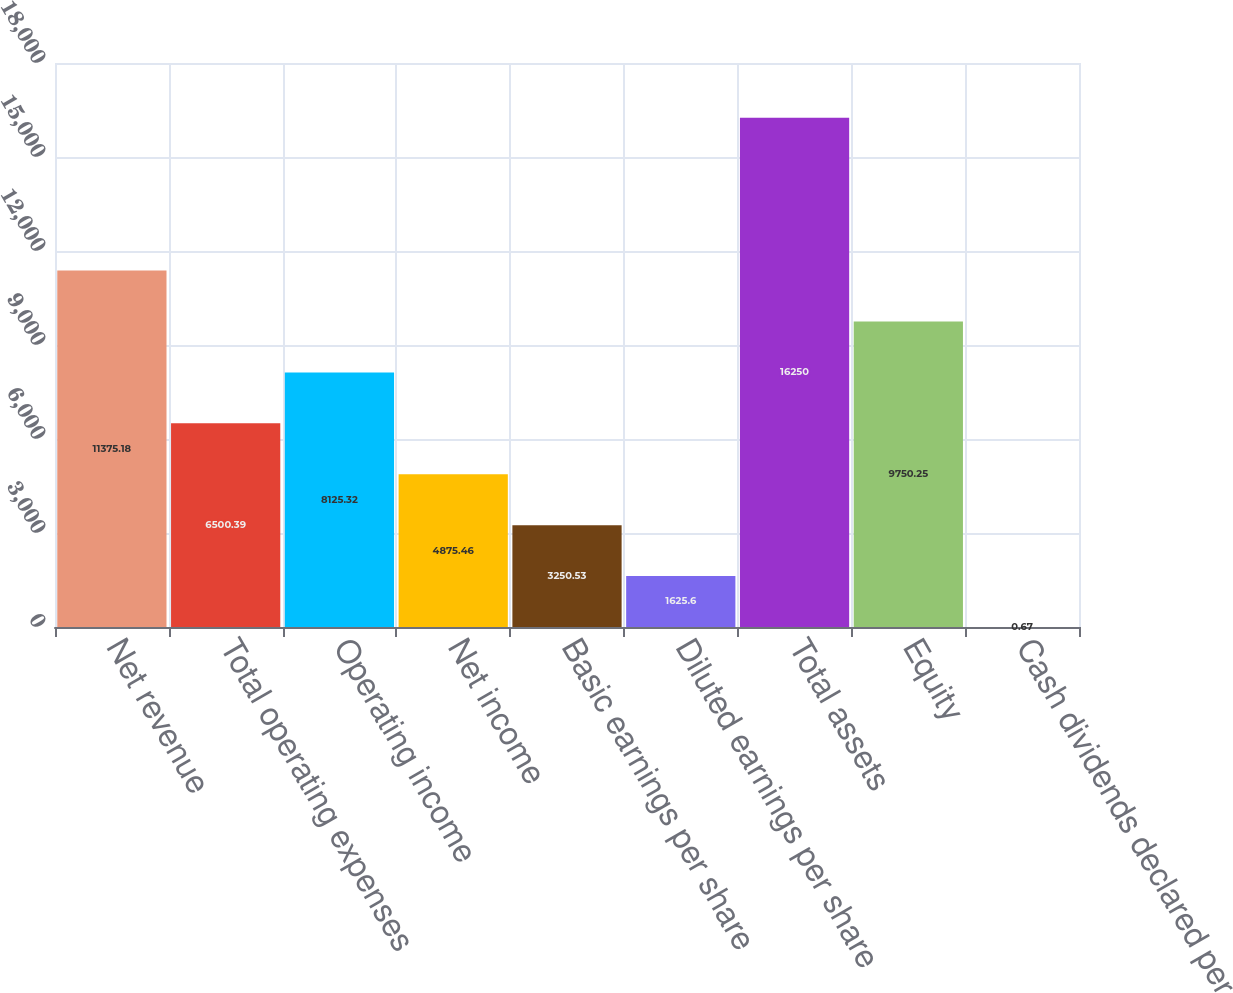<chart> <loc_0><loc_0><loc_500><loc_500><bar_chart><fcel>Net revenue<fcel>Total operating expenses<fcel>Operating income<fcel>Net income<fcel>Basic earnings per share<fcel>Diluted earnings per share<fcel>Total assets<fcel>Equity<fcel>Cash dividends declared per<nl><fcel>11375.2<fcel>6500.39<fcel>8125.32<fcel>4875.46<fcel>3250.53<fcel>1625.6<fcel>16250<fcel>9750.25<fcel>0.67<nl></chart> 